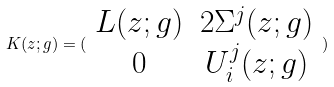<formula> <loc_0><loc_0><loc_500><loc_500>K ( z ; g ) = ( \begin{array} { c c } L ( z ; g ) & 2 \Sigma ^ { j } ( z ; g ) \\ 0 & U _ { i } ^ { j } ( z ; g ) \end{array} )</formula> 